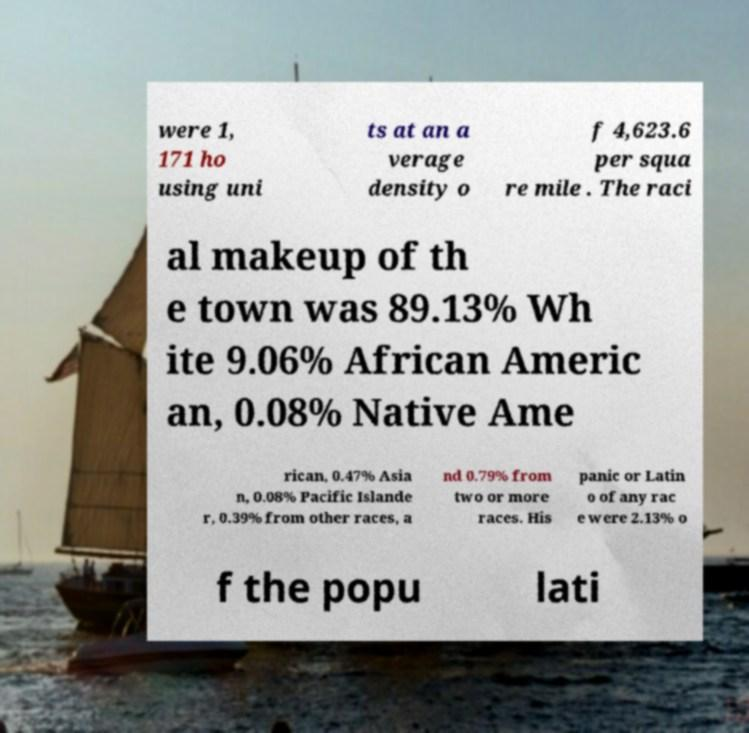What messages or text are displayed in this image? I need them in a readable, typed format. were 1, 171 ho using uni ts at an a verage density o f 4,623.6 per squa re mile . The raci al makeup of th e town was 89.13% Wh ite 9.06% African Americ an, 0.08% Native Ame rican, 0.47% Asia n, 0.08% Pacific Islande r, 0.39% from other races, a nd 0.79% from two or more races. His panic or Latin o of any rac e were 2.13% o f the popu lati 